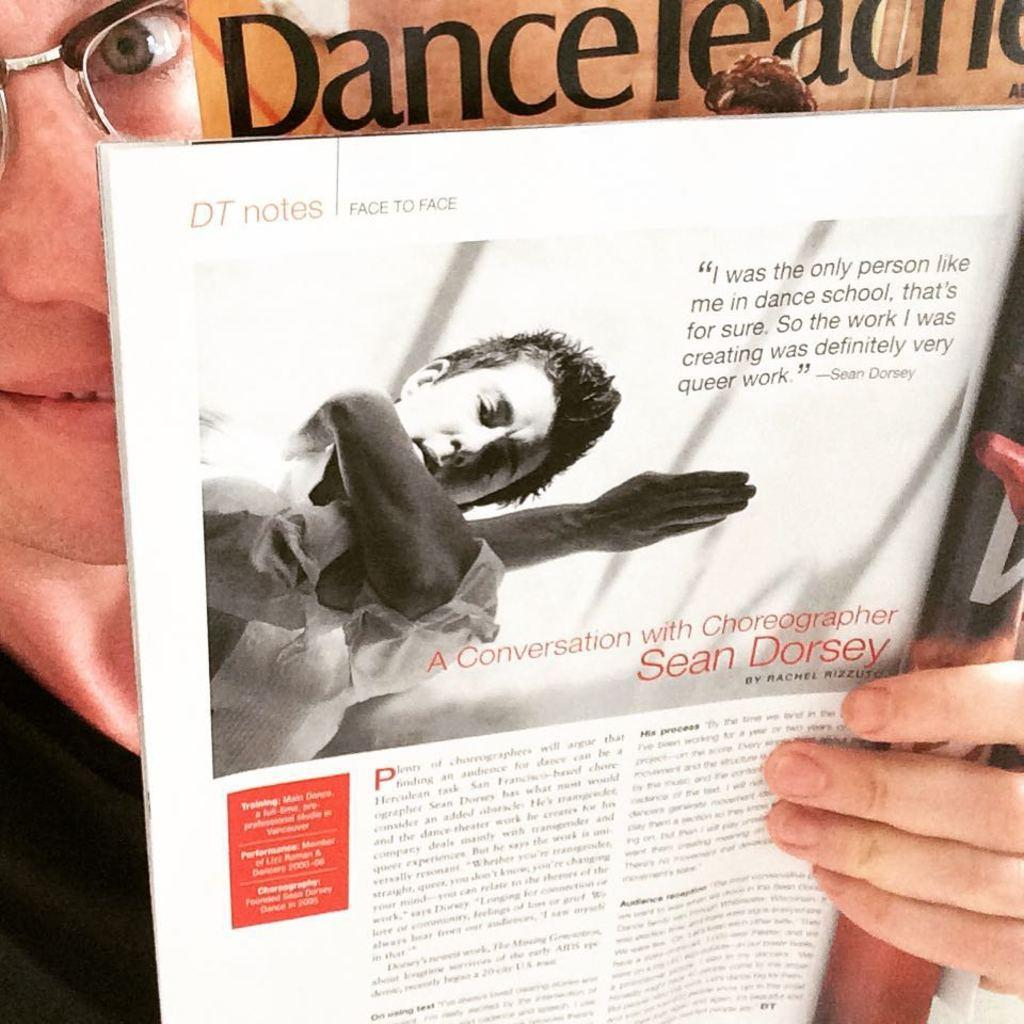<image>
Write a terse but informative summary of the picture. In this magazine you can read the article A Conversation with Choreographer Sean Dorsey. 